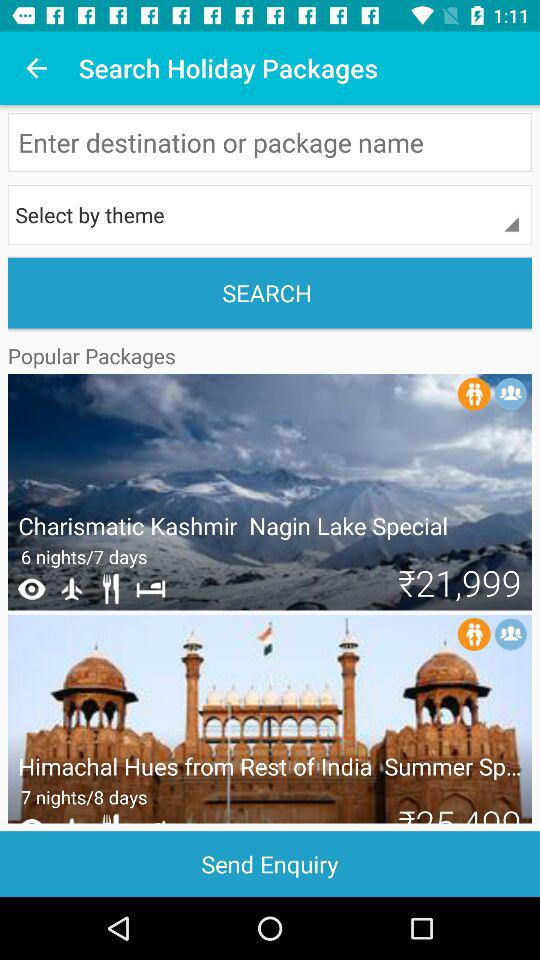How many more nights does the second package have than the first?
Answer the question using a single word or phrase. 1 